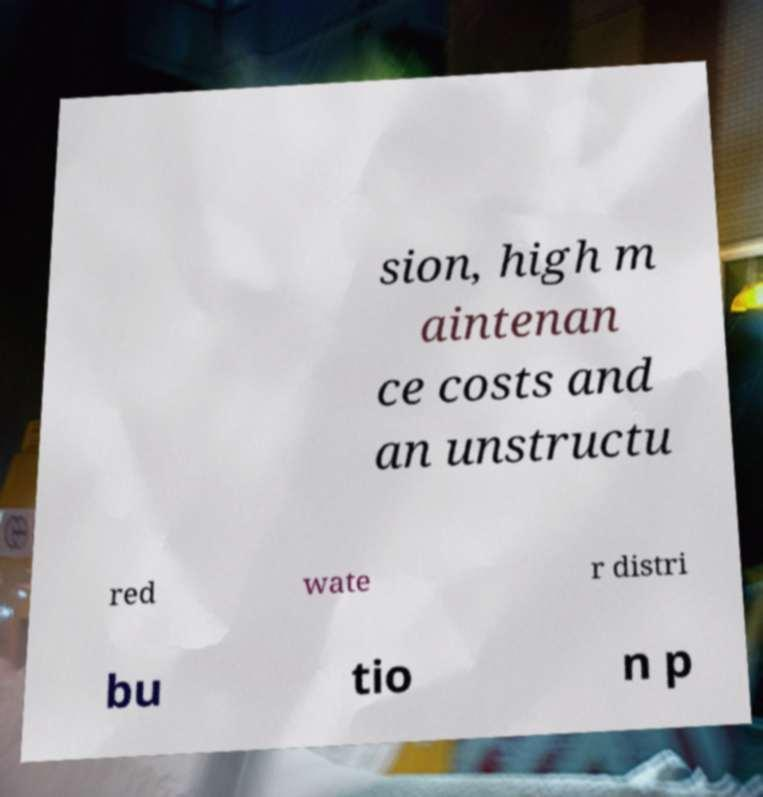Please read and relay the text visible in this image. What does it say? sion, high m aintenan ce costs and an unstructu red wate r distri bu tio n p 